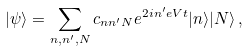<formula> <loc_0><loc_0><loc_500><loc_500>| \psi \rangle = \sum _ { n , n ^ { \prime } , N } c _ { n n ^ { \prime } N } e ^ { 2 i n ^ { \prime } e V t } | n \rangle | N \rangle \, ,</formula> 